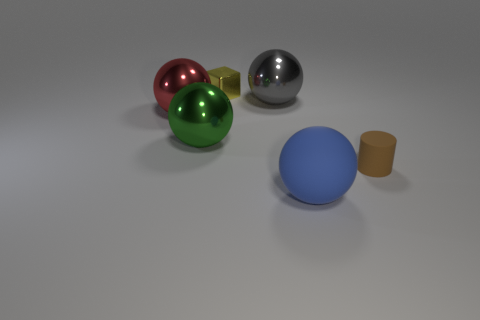Can you tell me what the small golden object might be used for? The small golden object resembles a cylinder and might serve as a simplistic representation of a container or a stand, perhaps in a minimalist decorative arrangement or as part of a set of basic geometric shapes for educational purposes. 